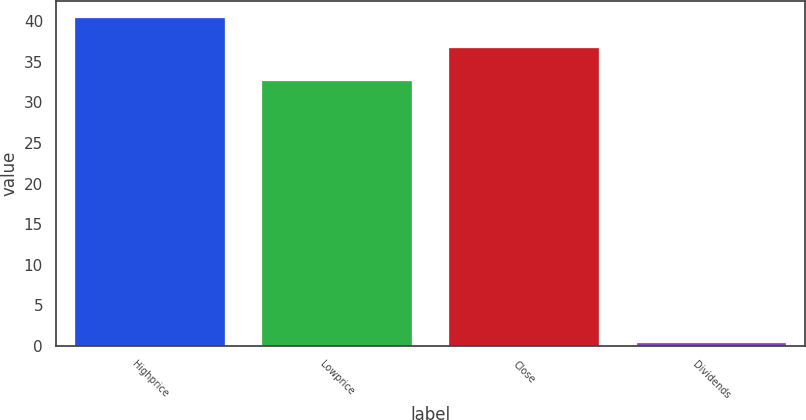<chart> <loc_0><loc_0><loc_500><loc_500><bar_chart><fcel>Highprice<fcel>Lowprice<fcel>Close<fcel>Dividends<nl><fcel>40.45<fcel>32.69<fcel>36.69<fcel>0.3<nl></chart> 